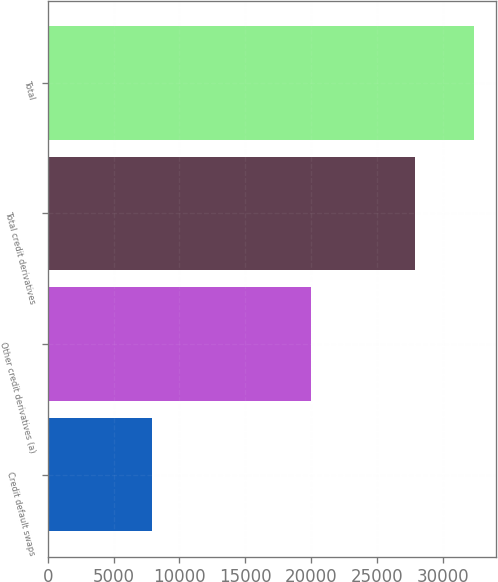Convert chart to OTSL. <chart><loc_0><loc_0><loc_500><loc_500><bar_chart><fcel>Credit default swaps<fcel>Other credit derivatives (a)<fcel>Total credit derivatives<fcel>Total<nl><fcel>7935<fcel>19991<fcel>27926<fcel>32431<nl></chart> 